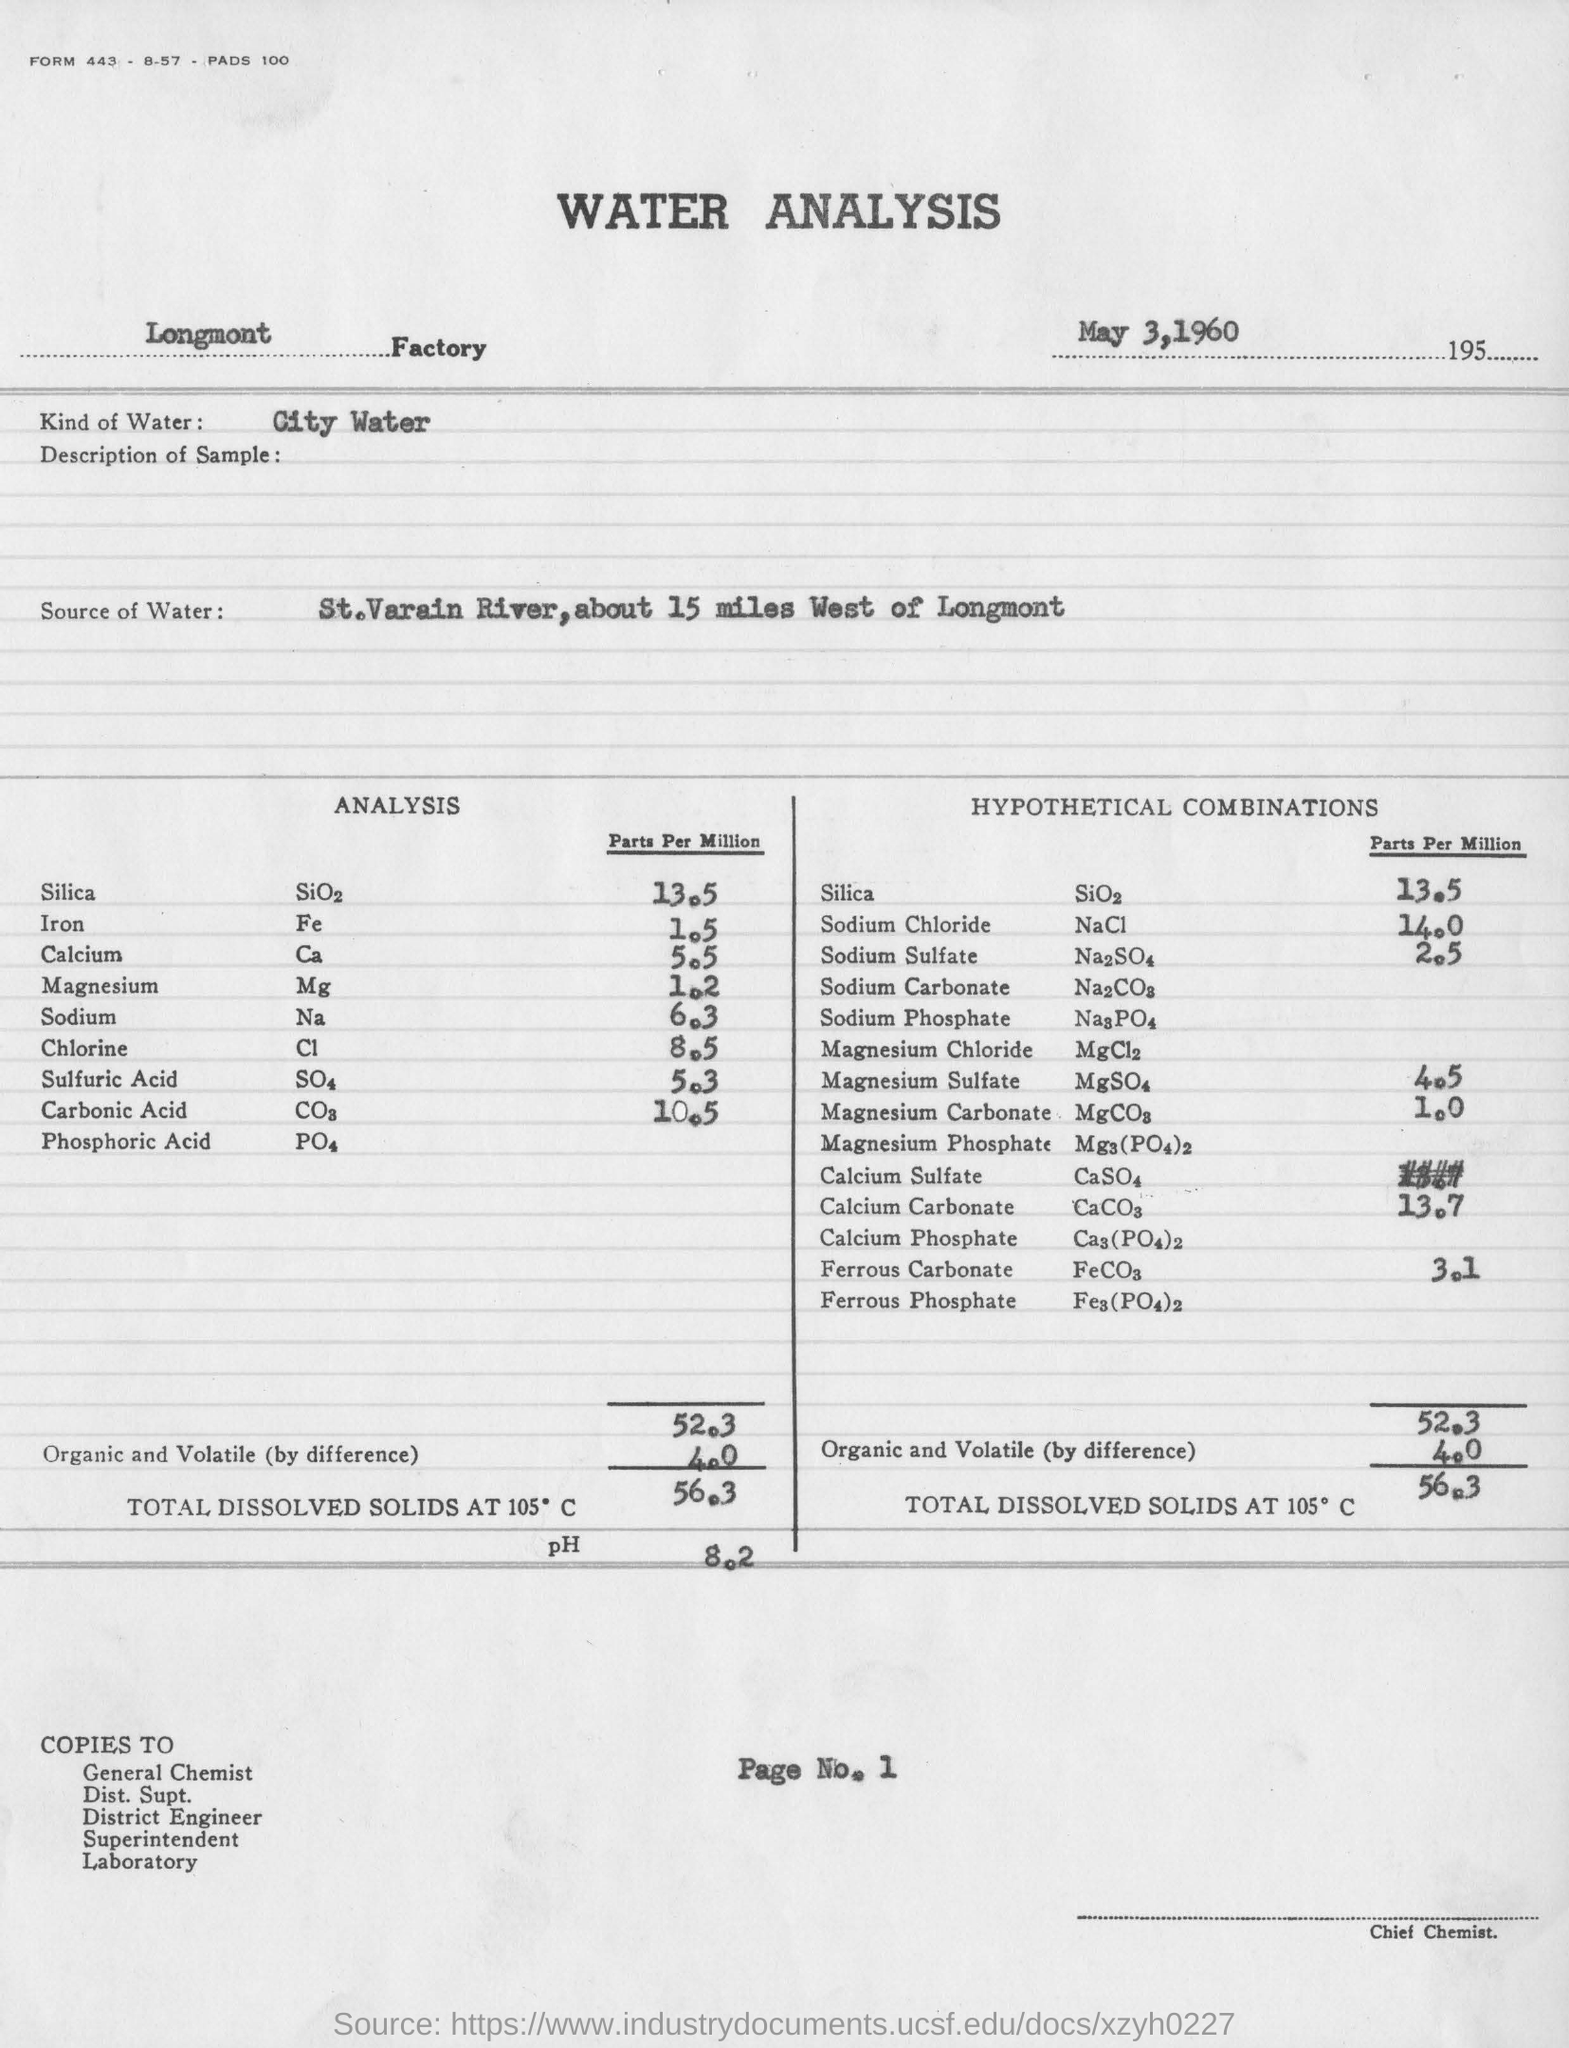Indicate a few pertinent items in this graphic. The report indicates that the factory name printed on this report is "Longmont". It has been determined that the water in question is city water. The date mentioned is May 3, 1960. The source of water is the St. Vrain River, which is located approximately 15 miles west of Longmont. The designation 'Chief Chemist' is located in the bottom right corner of the page. 